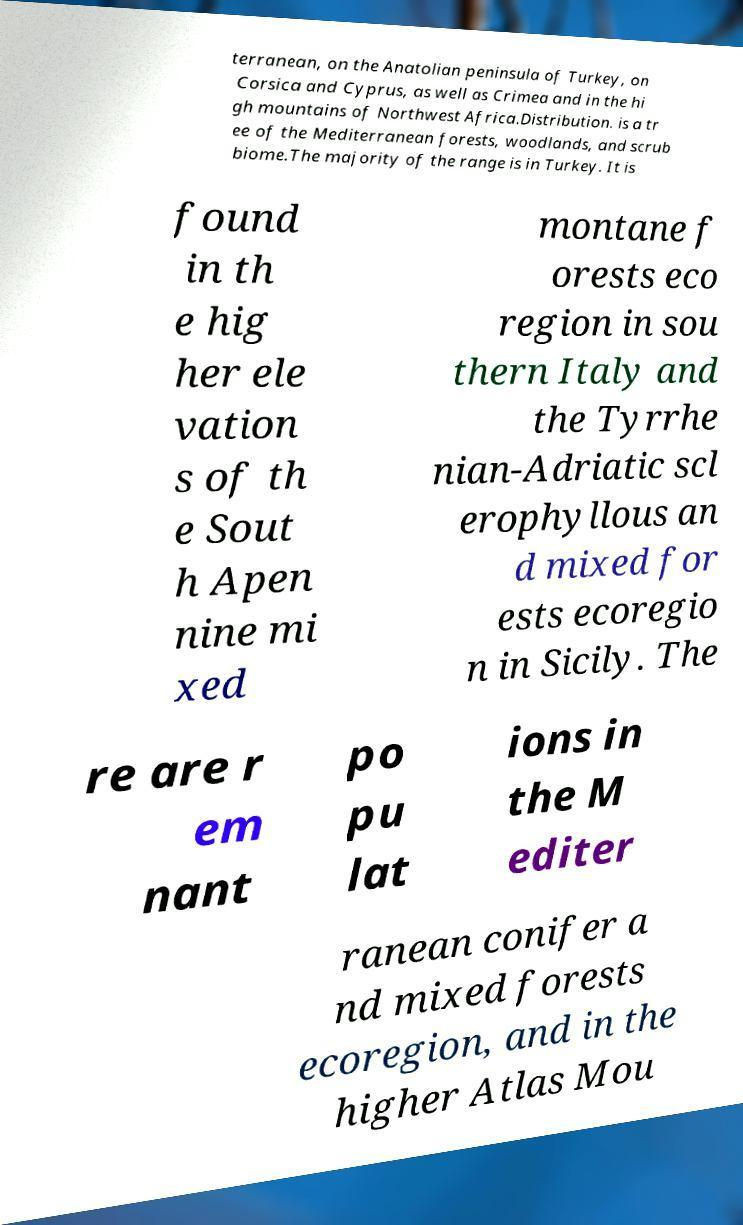Please read and relay the text visible in this image. What does it say? terranean, on the Anatolian peninsula of Turkey, on Corsica and Cyprus, as well as Crimea and in the hi gh mountains of Northwest Africa.Distribution. is a tr ee of the Mediterranean forests, woodlands, and scrub biome.The majority of the range is in Turkey. It is found in th e hig her ele vation s of th e Sout h Apen nine mi xed montane f orests eco region in sou thern Italy and the Tyrrhe nian-Adriatic scl erophyllous an d mixed for ests ecoregio n in Sicily. The re are r em nant po pu lat ions in the M editer ranean conifer a nd mixed forests ecoregion, and in the higher Atlas Mou 